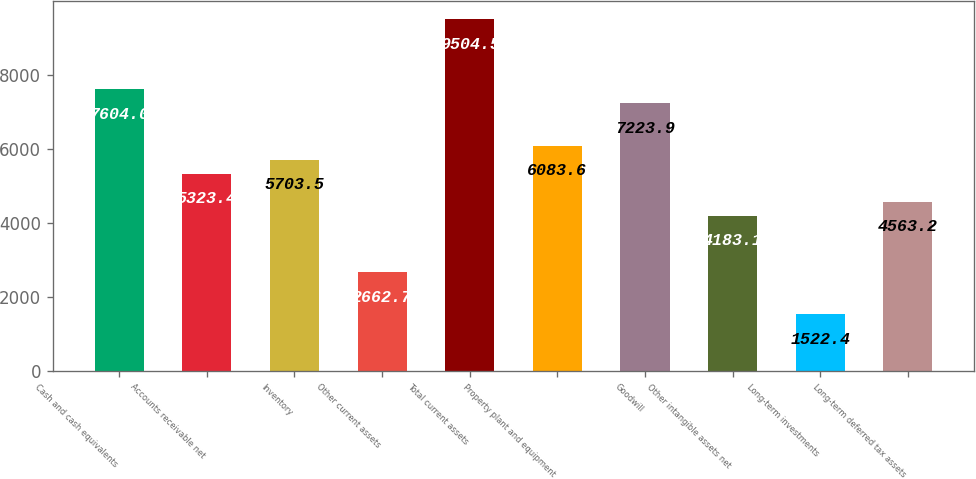Convert chart. <chart><loc_0><loc_0><loc_500><loc_500><bar_chart><fcel>Cash and cash equivalents<fcel>Accounts receivable net<fcel>Inventory<fcel>Other current assets<fcel>Total current assets<fcel>Property plant and equipment<fcel>Goodwill<fcel>Other intangible assets net<fcel>Long-term investments<fcel>Long-term deferred tax assets<nl><fcel>7604<fcel>5323.4<fcel>5703.5<fcel>2662.7<fcel>9504.5<fcel>6083.6<fcel>7223.9<fcel>4183.1<fcel>1522.4<fcel>4563.2<nl></chart> 